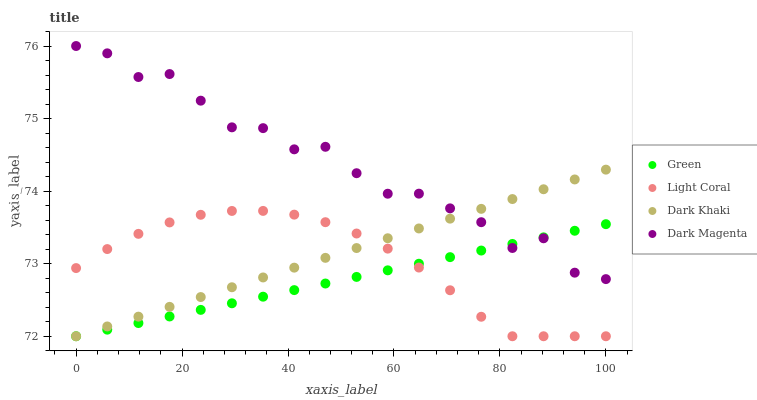Does Green have the minimum area under the curve?
Answer yes or no. Yes. Does Dark Magenta have the maximum area under the curve?
Answer yes or no. Yes. Does Dark Khaki have the minimum area under the curve?
Answer yes or no. No. Does Dark Khaki have the maximum area under the curve?
Answer yes or no. No. Is Dark Khaki the smoothest?
Answer yes or no. Yes. Is Dark Magenta the roughest?
Answer yes or no. Yes. Is Green the smoothest?
Answer yes or no. No. Is Green the roughest?
Answer yes or no. No. Does Light Coral have the lowest value?
Answer yes or no. Yes. Does Dark Magenta have the lowest value?
Answer yes or no. No. Does Dark Magenta have the highest value?
Answer yes or no. Yes. Does Dark Khaki have the highest value?
Answer yes or no. No. Is Light Coral less than Dark Magenta?
Answer yes or no. Yes. Is Dark Magenta greater than Light Coral?
Answer yes or no. Yes. Does Dark Magenta intersect Dark Khaki?
Answer yes or no. Yes. Is Dark Magenta less than Dark Khaki?
Answer yes or no. No. Is Dark Magenta greater than Dark Khaki?
Answer yes or no. No. Does Light Coral intersect Dark Magenta?
Answer yes or no. No. 